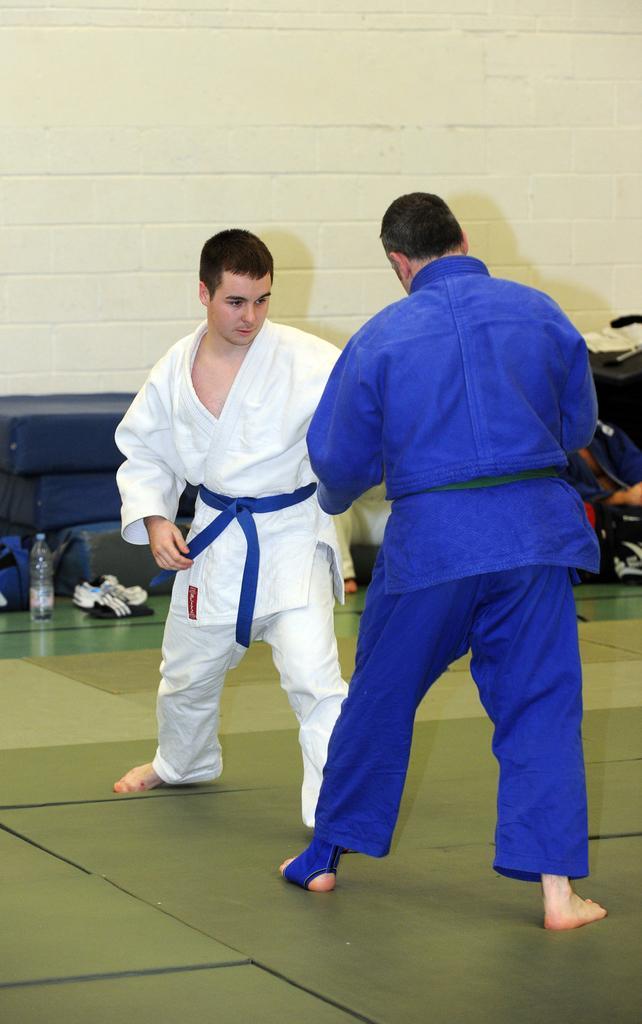In one or two sentences, can you explain what this image depicts? This picture seems to be clicked inside the room and we can see the group of people and in the center, we can see the two people standing on the ground. In the background, we can see the wall and we can see the bottle and some other items are placed on the ground and we can see the group of people seems to be sitting and we can see some other items in the background. 